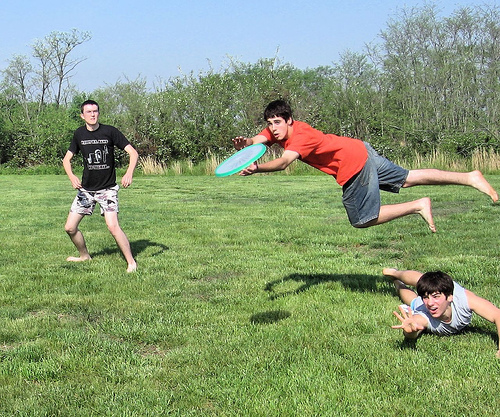Please provide a short description for this region: [0.08, 0.25, 0.31, 0.73]. A person wearing knee-length shorts. 